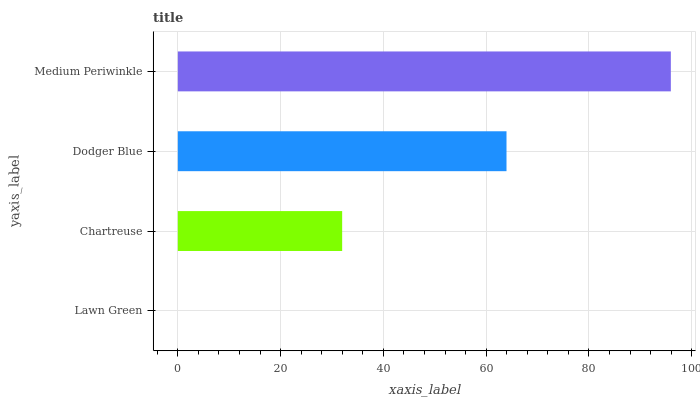Is Lawn Green the minimum?
Answer yes or no. Yes. Is Medium Periwinkle the maximum?
Answer yes or no. Yes. Is Chartreuse the minimum?
Answer yes or no. No. Is Chartreuse the maximum?
Answer yes or no. No. Is Chartreuse greater than Lawn Green?
Answer yes or no. Yes. Is Lawn Green less than Chartreuse?
Answer yes or no. Yes. Is Lawn Green greater than Chartreuse?
Answer yes or no. No. Is Chartreuse less than Lawn Green?
Answer yes or no. No. Is Dodger Blue the high median?
Answer yes or no. Yes. Is Chartreuse the low median?
Answer yes or no. Yes. Is Medium Periwinkle the high median?
Answer yes or no. No. Is Dodger Blue the low median?
Answer yes or no. No. 